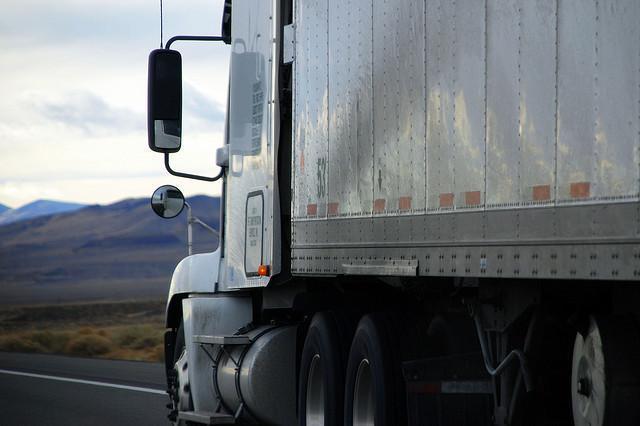How many mirrors are visible on the side of the truck?
Give a very brief answer. 2. 